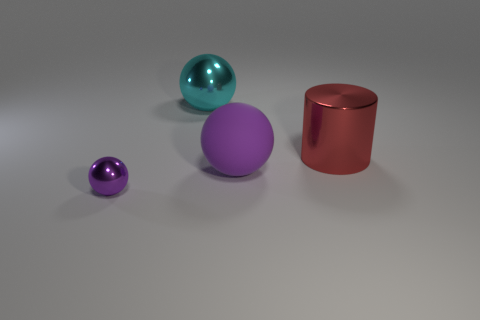Subtract all small purple spheres. How many spheres are left? 2 Subtract all cyan cylinders. How many purple balls are left? 2 Subtract 1 spheres. How many spheres are left? 2 Add 3 purple balls. How many objects exist? 7 Subtract all balls. How many objects are left? 1 Subtract 0 blue spheres. How many objects are left? 4 Subtract all yellow balls. Subtract all green cylinders. How many balls are left? 3 Subtract all small purple things. Subtract all large matte objects. How many objects are left? 2 Add 3 spheres. How many spheres are left? 6 Add 3 big blue metallic blocks. How many big blue metallic blocks exist? 3 